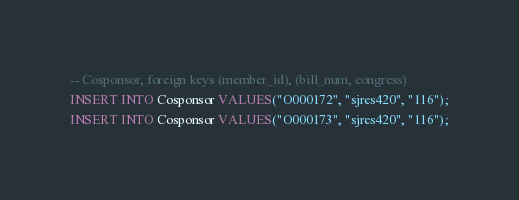<code> <loc_0><loc_0><loc_500><loc_500><_SQL_>-- Cosponsor, foreign keys (member_id), (bill_num, congress)
INSERT INTO Cosponsor VALUES("O000172", "sjres420", "116");
INSERT INTO Cosponsor VALUES("O000173", "sjres420", "116");</code> 